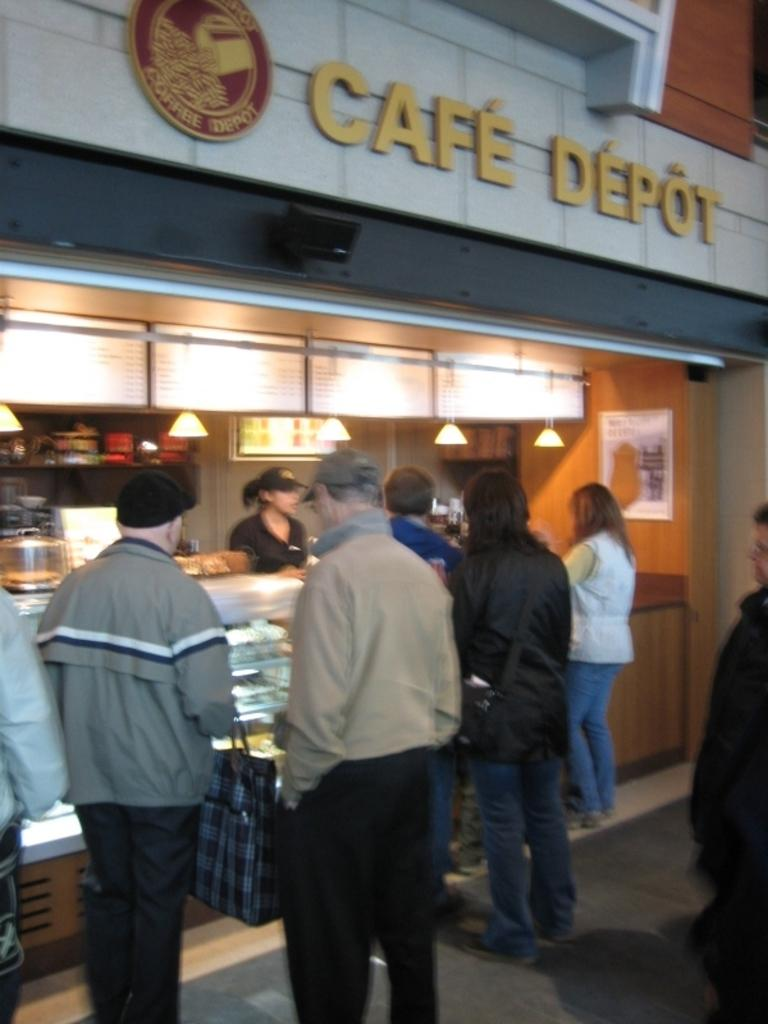What is the name of the shop in the image? There is a shop named "Cafe Depot" in the image. Can you describe the scene outside the shop? There are many people standing behind the shop in the image. Who is present inside the shop? There is a shopkeeper present in the shop. What type of scent can be smelled coming from the room in the image? There is no room present in the image, so it is not possible to determine what scent might be smelled. 